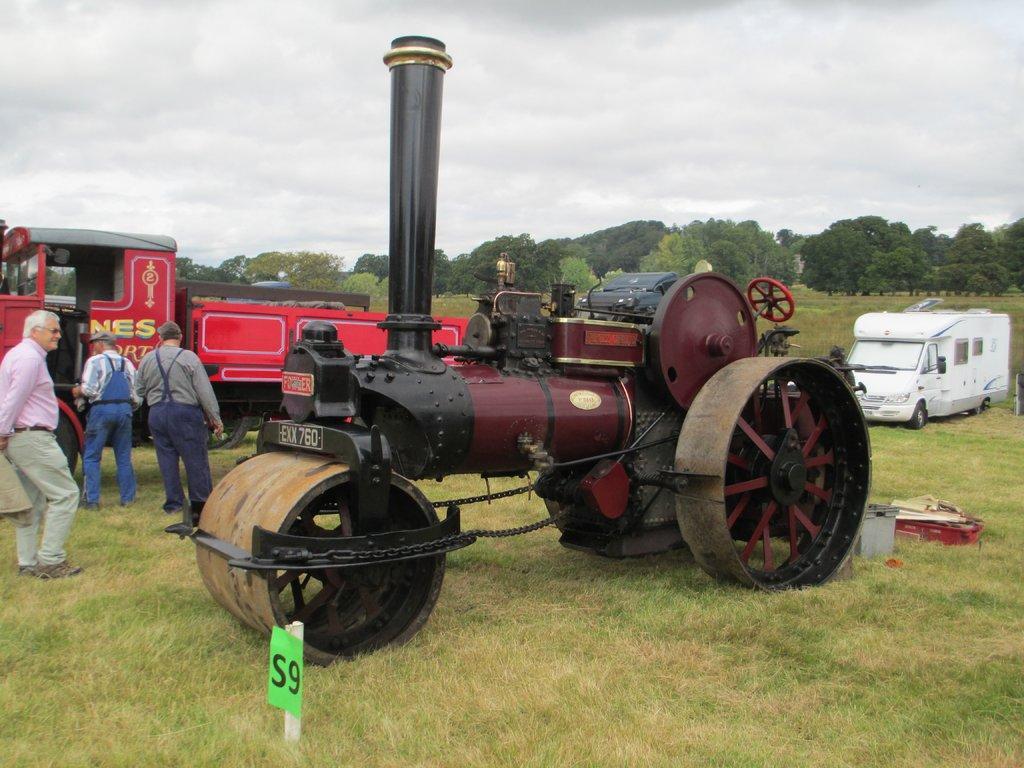Could you give a brief overview of what you see in this image? In this image there are vehicles on a grassland and there are there are three people standing, in the background there are trees and the sky. 